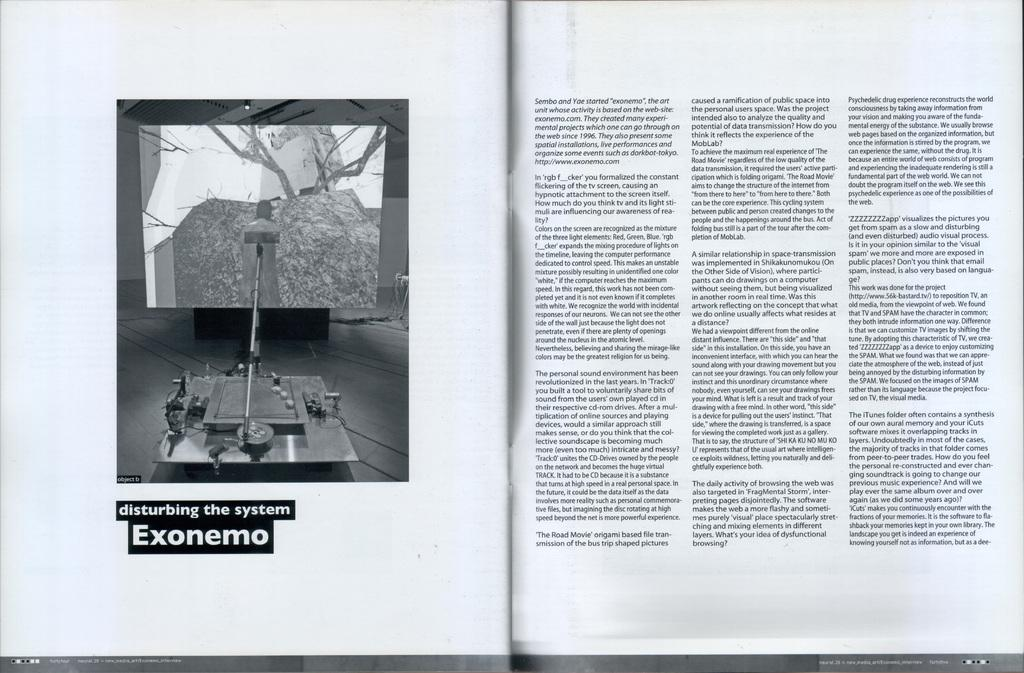<image>
Summarize the visual content of the image. A book open to a page with the title disturbing the system Exonemo. 